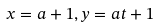Convert formula to latex. <formula><loc_0><loc_0><loc_500><loc_500>x = a + 1 , y = a t + 1</formula> 